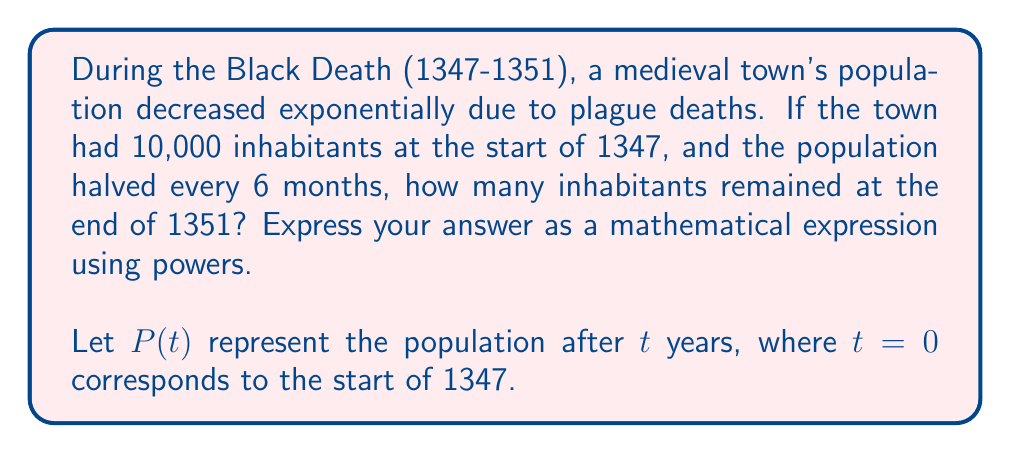Give your solution to this math problem. To solve this problem, we'll follow these steps:

1) First, let's establish our exponential decay formula:
   $$P(t) = P_0 \cdot (1/2)^{2t}$$
   where $P_0$ is the initial population (10,000), and $t$ is time in years.

2) We use $(1/2)^{2t}$ because the population halves every 6 months, which is twice per year.

3) Now, we need to calculate for $t = 5$ years (from start of 1347 to end of 1351):
   $$P(5) = 10000 \cdot (1/2)^{2 \cdot 5}$$

4) Simplify the exponent:
   $$P(5) = 10000 \cdot (1/2)^{10}$$

5) This can be written as:
   $$P(5) = 10000 \cdot \frac{1}{2^{10}}$$

6) We could calculate this further, but the question asks for the answer as a mathematical expression using powers.

Note: This model assumes a continuous exponential decay, which is a simplification of the actual historical events. In reality, the spread of the plague was more complex and varied between regions.
Answer: $10000 \cdot \frac{1}{2^{10}}$ 